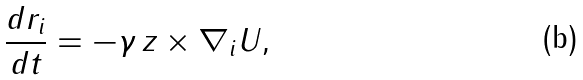<formula> <loc_0><loc_0><loc_500><loc_500>\frac { d { r } _ { i } } { d t } = - \gamma \, { z } \times \nabla _ { i } U ,</formula> 